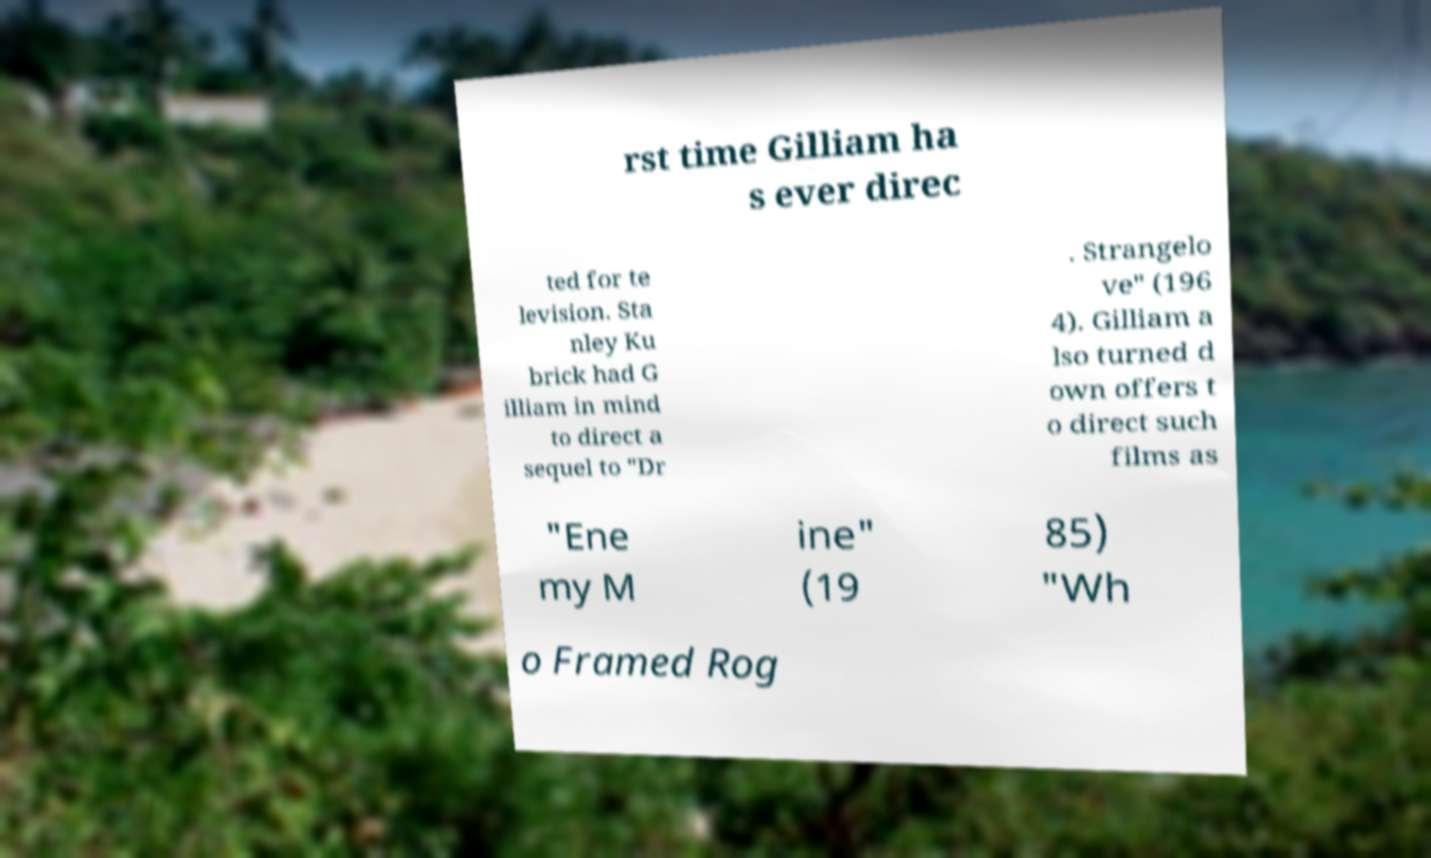Can you read and provide the text displayed in the image?This photo seems to have some interesting text. Can you extract and type it out for me? rst time Gilliam ha s ever direc ted for te levision. Sta nley Ku brick had G illiam in mind to direct a sequel to "Dr . Strangelo ve" (196 4). Gilliam a lso turned d own offers t o direct such films as "Ene my M ine" (19 85) "Wh o Framed Rog 